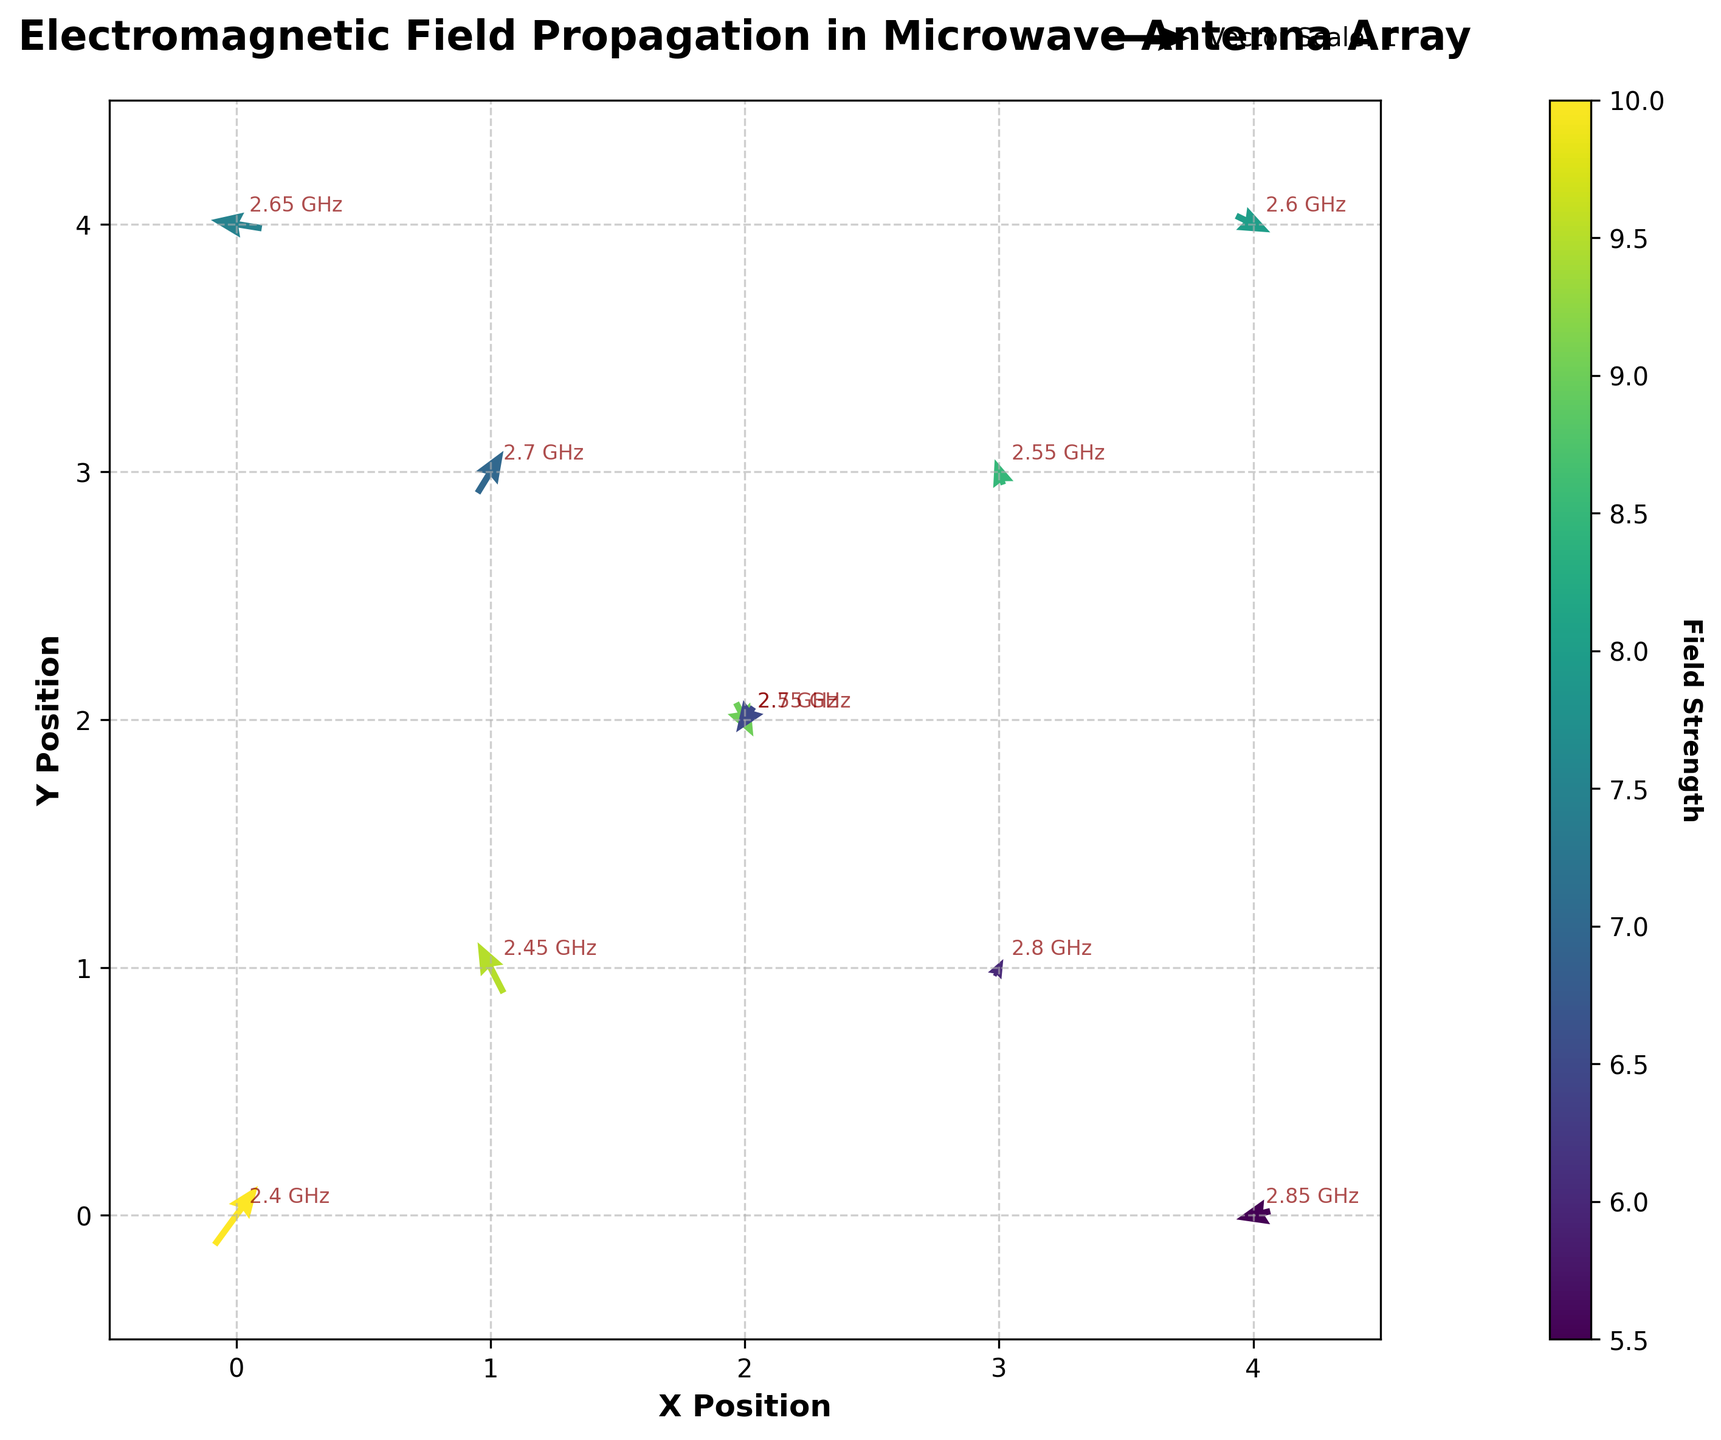What is the title of the plot? The title is displayed at the top center of the plot. It reads "Electromagnetic Field Propagation in Microwave Antenna Array".
Answer: Electromagnetic Field Propagation in Microwave Antenna Array What does the color of the arrows represent? The color of the arrows is determined by the field strength, which is shown in the colorbar on the right side of the plot. The color changes according to the field strength value.
Answer: Field strength Where is the highest field strength located? To determine the highest field strength, refer to the colorbar to match the darkest hue. Locate this color on the plot, and note the position.
Answer: At (0, 0) What is the frequency at the position (4,4)? The frequency annotations are next to each arrow. At the position (4,4), the annotation next to the arrow states "2.6 GHz".
Answer: 2.6 GHz How many different frequencies are annotated on the plot? To find the number of different frequencies, count each unique frequency annotation displayed next to the arrows. There are frequencies from 2.4 GHz to 2.85 GHz with an increment of 0.05 GHz.
Answer: 10 Which position has the lowest field strength? Check the colorbar to identify the hue representing the lowest field strength. Locate this hue on the plot and note the corresponding position.
Answer: At (4, 0) Compare the vector directions at positions (0,0) and (4,0). The plot shows the direction and magnitude of vectors. At (0,0), the vector points mostly upwards to the right, while at (4,0), it points slightly downwards and to the left.
Answer: (0, 0) is up-right; (4, 0) is down-left What is the change in field strength from the position (0,4) to (4,4)? Refer to the color of the arrows at these positions and match them to values in the colorbar. Subtract the field strength at (4,4) from that at (0,4).
Answer: 7.5 - 8 = 0.5 How can you identify the vector direction at position (2,2)? The vector at (2,2) is pointing downwards and slightly to the left. This can be identified by looking at the arrow direction in the plot at the coordinate.
Answer: Down-left What is the magnitude and direction of the vector at position (3, 3)? The vector at (3,3) is pointing upwards and slightly to the right. By observing the arrow's length and direction, the magnitude appears small.
Answer: Up-right 